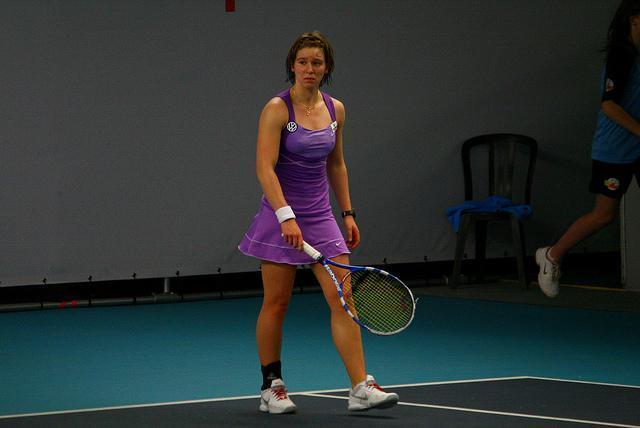How many people are there?
Give a very brief answer. 2. 